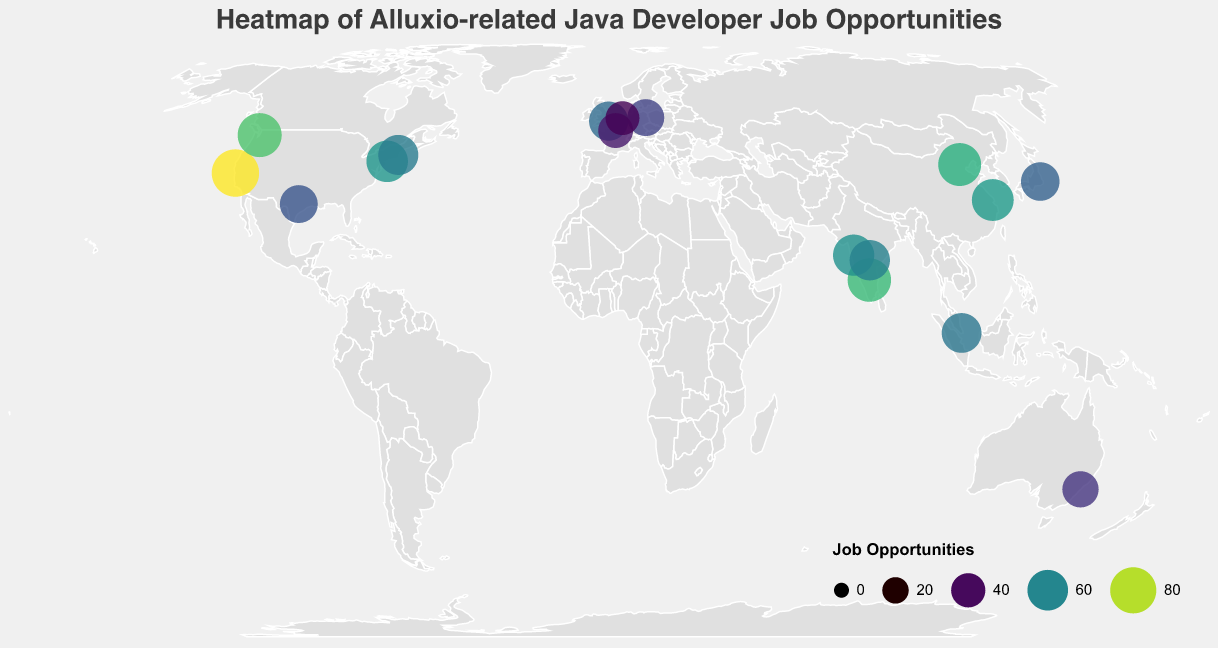Which city has the highest number of job opportunities? By examining the size and color of the circles in the heatmap, the largest and darkest circle represents the city with the most job opportunities. According to the data, San Francisco has the highest number of job opportunities.
Answer: San Francisco What is the title of the figure? The title of the figure is generally located at the top-center. In this case, it is clearly mentioned in the "title" element of the plot.
Answer: Heatmap of Alluxio-related Java Developer Job Opportunities Which city in India has the highest number of job opportunities? By looking for the cities in India and comparing their job opportunities, Bangalore has the highest number of job opportunities among the Indian cities displayed.
Answer: Bangalore What is the combined number of job opportunities for cities in the USA? The cities in the USA are San Francisco, Seattle, New York, Boston, and Austin. Summing their job opportunities: 85 (San Francisco) + 72 (Seattle) + 63 (New York) + 58 (Boston) + 51 (Austin) = 329.
Answer: 329 Which country has the second highest total job opportunities if we sum the values for its cities? To find this, calculate the sum of job opportunities for cities in each country and then rank them. The USA has 329 jobs (San Francisco, Seattle, New York, Boston, Austin), the second highest will be India with 70 (Bangalore) + 62 (Pune) + 59 (Hyderabad) = 191.
Answer: India Which cities in the data have fewer than 50 job opportunities? By checking the data and visual inspection, the cities with fewer than 50 job opportunities are Berlin (48), Paris (42), Amsterdam (39), and Sydney (46).
Answer: Berlin, Paris, Amsterdam, Sydney What is the average number of job opportunities in cities from China? The Chinese cities listed are Beijing and Shanghai. Their job opportunities are 68 (Beijing) and 64 (Shanghai). The average is (68 + 64) / 2 = 66.
Answer: 66 Are there more job opportunities in European cities or in Australian cities? Summing the job opportunities for European cities (London 55, Berlin 48, Paris 42, Amsterdam 39) gives 184, while Sydney alone has 46 job opportunities. Therefore, Europe has more job opportunities.
Answer: Europe Which city has the closest job opportunity number to Tokyo? Tokyo has 53 job opportunities. Sydney, with 46 job opportunities, is the closest to this number when comparing the differences.
Answer: Sydney Which city in the plot has the largest circle, and what does it represent? The largest circle in the heatmap represents the city with the highest number of job opportunities. According to the data, San Francisco has the largest circle.
Answer: San Francisco (85 job opportunities) 